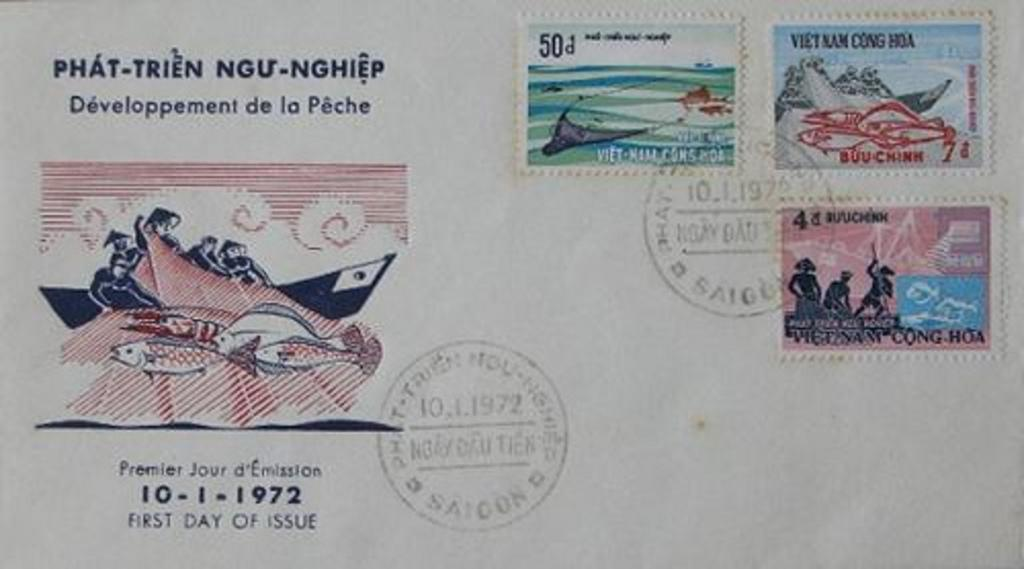<image>
Relay a brief, clear account of the picture shown. A postmarked letter with the date of October 1, 1972. 